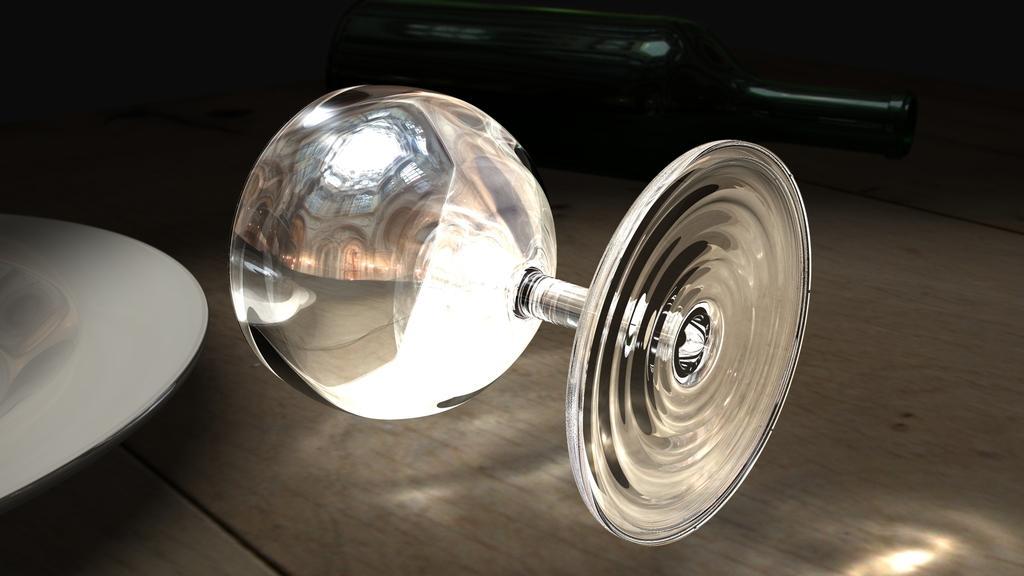In one or two sentences, can you explain what this image depicts? In this image I can see a glass and in background I can see a bottle. I can see this image is little bit in dark and here I can see white colour thing. 